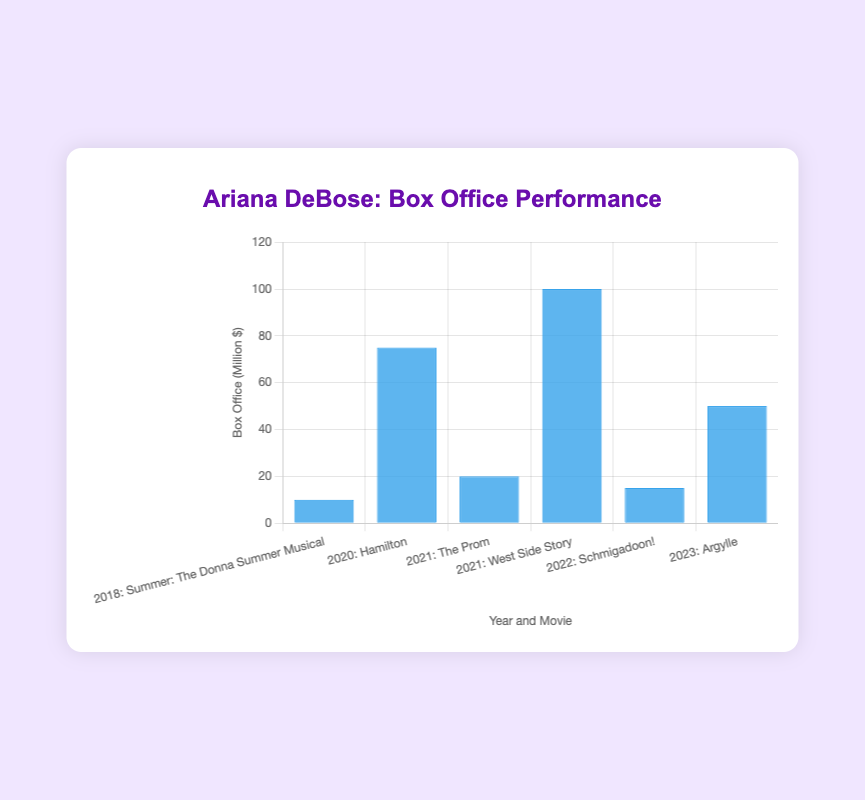Which movie had the highest box office performance? By looking at the tallest bar in the figure, we can identify the movie associated with it. The highest bar represents the movie with the highest box office earnings.
Answer: West Side Story What is the combined box office earnings for movies released in 2021? Sum the box office earnings of "The Prom" and "West Side Story" released in 2021. The Prom earned $20 million and West Side Story earned $100 million. 20 + 100 = 120
Answer: 120 million Which movie had a lower box office performance: "Hamilton" or "Argylle"? Compare the heights of the bars for "Hamilton" and "Argylle". The bar for "Hamilton" is taller (75 million) than the bar for "Argylle" (50 million), which means "Hamilton" had a higher box office performance. So, "Argylle" had a lower performance.
Answer: Argylle How much more did "West Side Story" earn compared to "Summer: The Donna Summer Musical"? Subtract the box office earnings of "Summer: The Donna Summer Musical" ($10 million) from "West Side Story" ($100 million). 100 - 10 = 90
Answer: 90 million On average, how much did the movies starring Ariana DeBose earn at the box office? To calculate the average, sum all the box office earnings and divide by the number of movies. (10 + 75 + 20 + 100 + 15 + 50) / 6 = 270 / 6 = 45
Answer: 45 million What can you say about the year 2021 in terms of Ariana DeBose's box office performance? In 2021, Ariana DeBose starred in two movies: "The Prom" and "West Side Story", which in total earned $120 million. This is notable as it is a combined high for a single year.
Answer: Released two movies, total $120 million Which year had the lowest box office performance for Ariana DeBose? Identify the year associated with the shortest bar in the figure. The shortest bar corresponds to the year 2018 with "Summer: The Donna Summer Musical" earning $10 million.
Answer: 2018 How does the box office performance of "Schmigadoon!" compare to "The Prom"? Compare the heights of the bars for "Schmigadoon!" and "The Prom". The bar for "The Prom" ($20 million) is taller than the bar for "Schmigadoon!" ($15 million).
Answer: The Prom earned more What is the median box office performance of the movies? To find the median, list the earnings in ascending order: $10, $15, $20, $50, $75, $100. The middle values are $20 and $50; the median is their average (20 + 50) / 2 = 35.
Answer: 35 million 